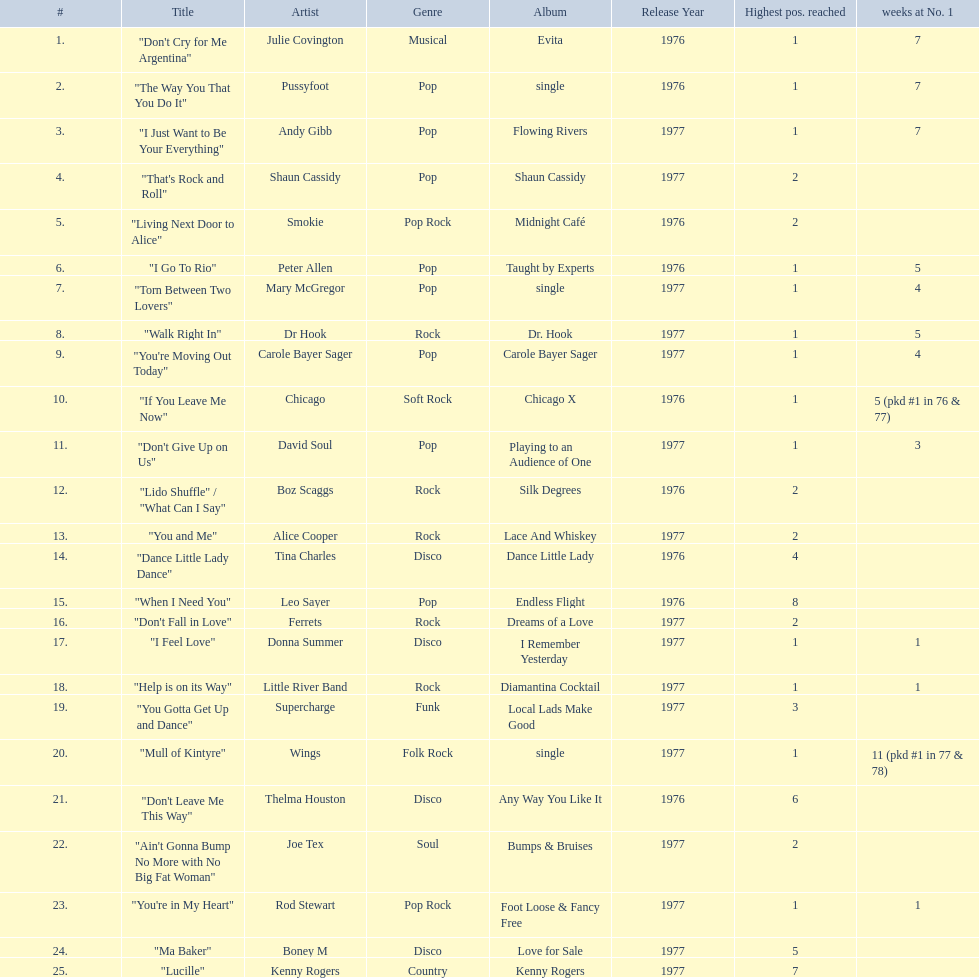Which song stayed at no.1 for the most amount of weeks. "Mull of Kintyre". 